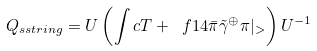<formula> <loc_0><loc_0><loc_500><loc_500>Q _ { s s t r i n g } = U \left ( \int c T + \ f { 1 } { 4 } \bar { \pi } \tilde { \gamma } ^ { \oplus } \pi | _ { > } \right ) U ^ { - 1 }</formula> 